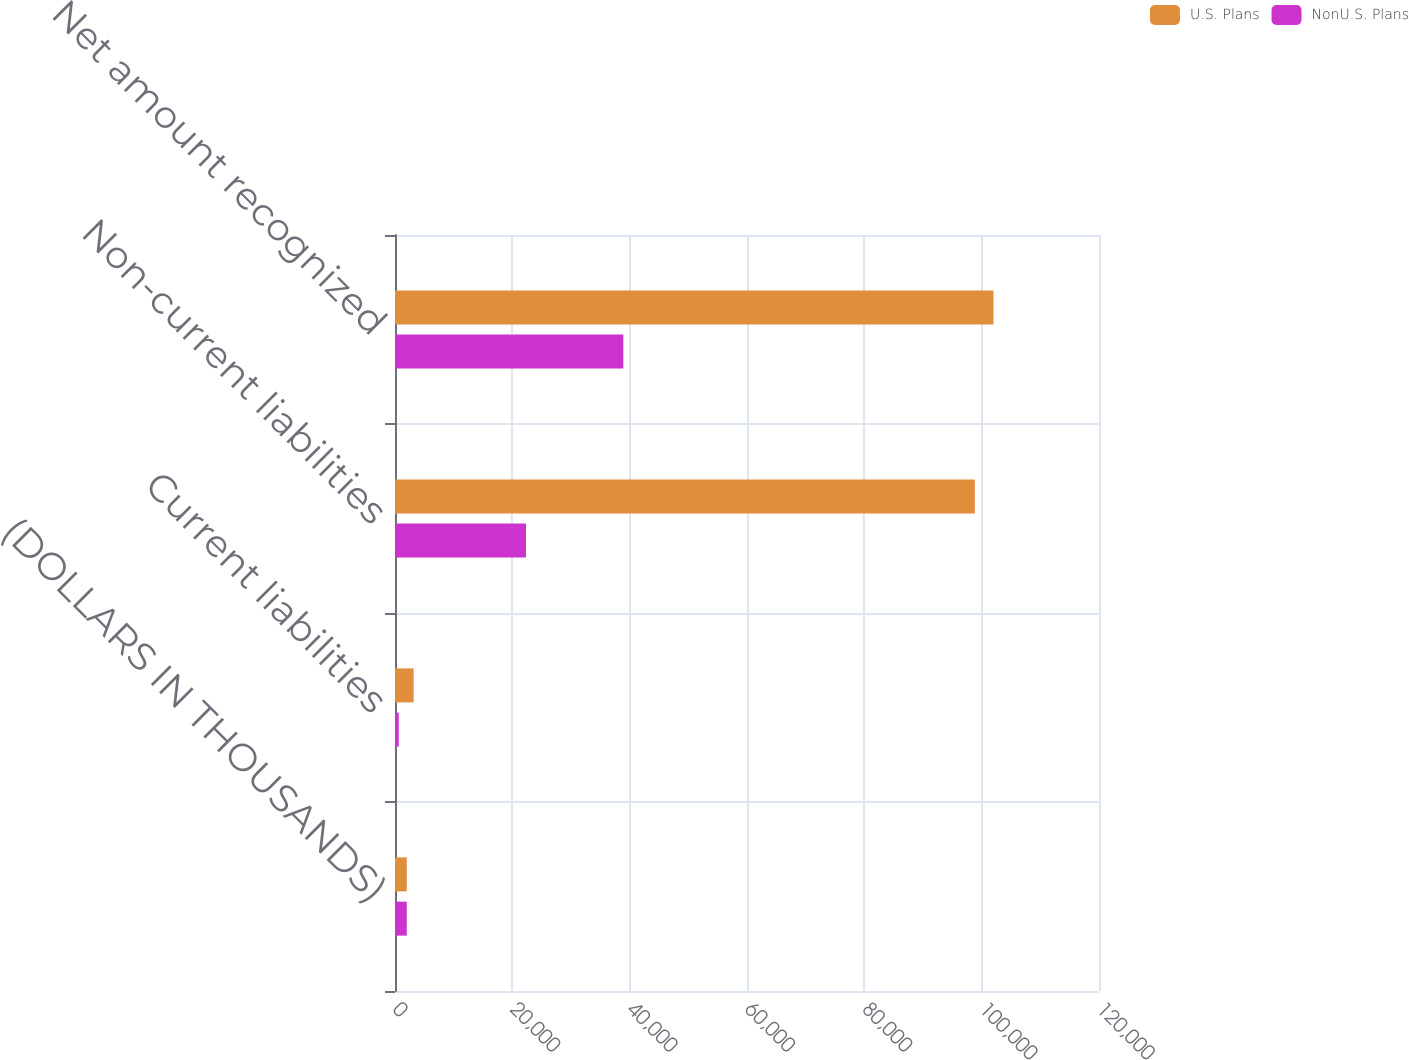Convert chart to OTSL. <chart><loc_0><loc_0><loc_500><loc_500><stacked_bar_chart><ecel><fcel>(DOLLARS IN THOUSANDS)<fcel>Current liabilities<fcel>Non-current liabilities<fcel>Net amount recognized<nl><fcel>U.S. Plans<fcel>2009<fcel>3175<fcel>98836<fcel>102011<nl><fcel>NonU.S. Plans<fcel>2009<fcel>636<fcel>22328<fcel>38917<nl></chart> 